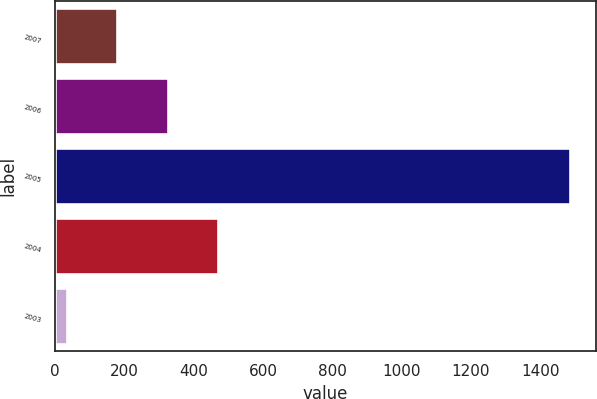Convert chart to OTSL. <chart><loc_0><loc_0><loc_500><loc_500><bar_chart><fcel>2007<fcel>2006<fcel>2005<fcel>2004<fcel>2003<nl><fcel>180.07<fcel>325.14<fcel>1485.7<fcel>470.21<fcel>35<nl></chart> 